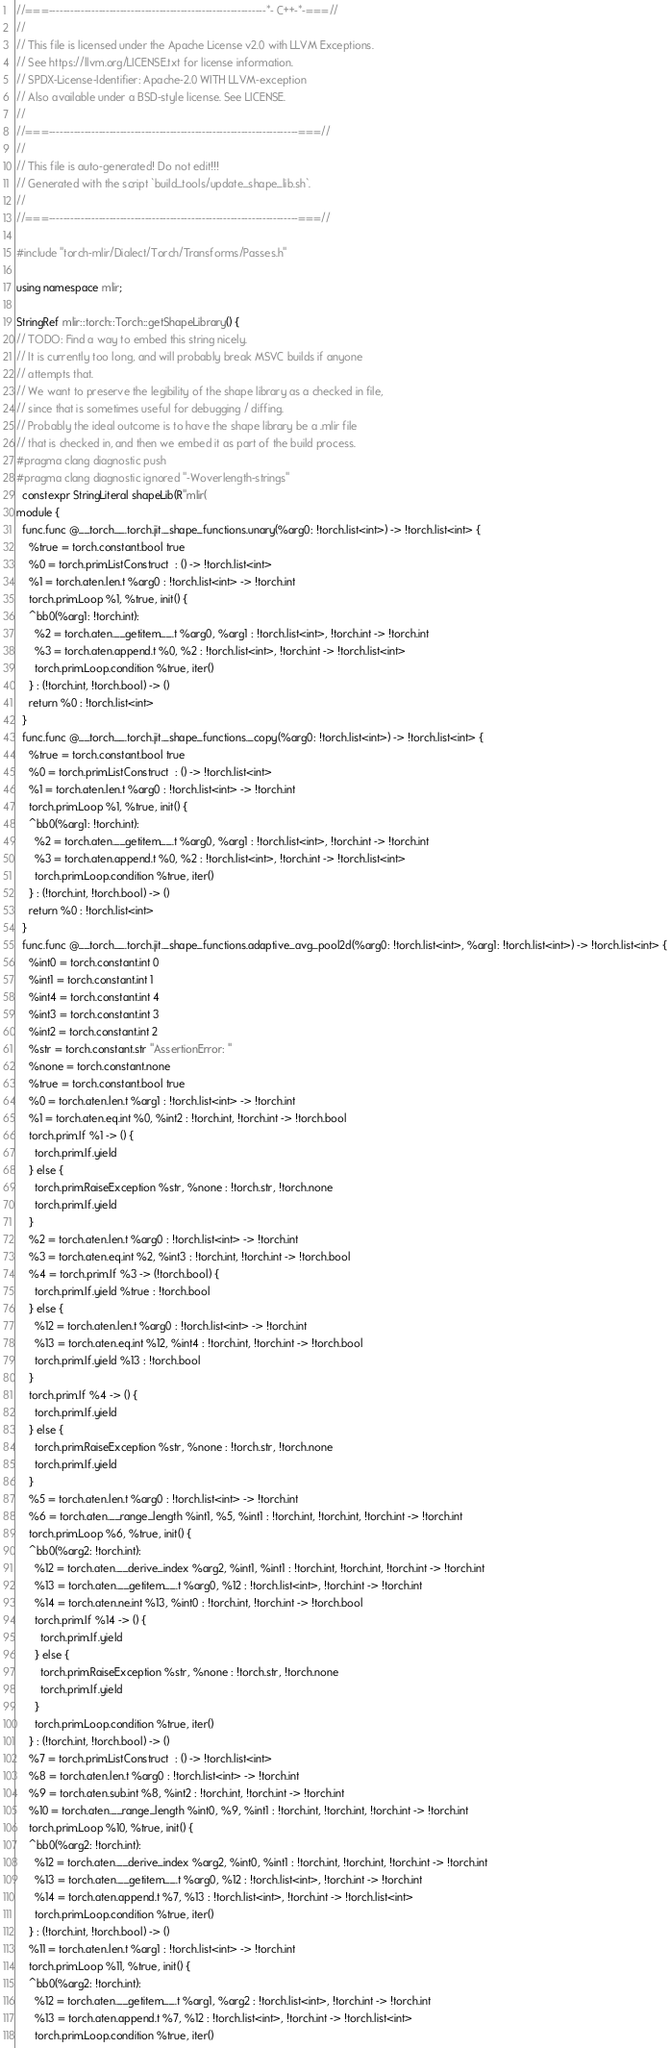<code> <loc_0><loc_0><loc_500><loc_500><_C++_>//===-------------------------------------------------------------*- C++-*-===//
//
// This file is licensed under the Apache License v2.0 with LLVM Exceptions.
// See https://llvm.org/LICENSE.txt for license information.
// SPDX-License-Identifier: Apache-2.0 WITH LLVM-exception
// Also available under a BSD-style license. See LICENSE.
//
//===----------------------------------------------------------------------===//
//
// This file is auto-generated! Do not edit!!!
// Generated with the script `build_tools/update_shape_lib.sh`.
//
//===----------------------------------------------------------------------===//

#include "torch-mlir/Dialect/Torch/Transforms/Passes.h"

using namespace mlir;

StringRef mlir::torch::Torch::getShapeLibrary() {
// TODO: Find a way to embed this string nicely.
// It is currently too long, and will probably break MSVC builds if anyone
// attempts that.
// We want to preserve the legibility of the shape library as a checked in file,
// since that is sometimes useful for debugging / diffing.
// Probably the ideal outcome is to have the shape library be a .mlir file
// that is checked in, and then we embed it as part of the build process.
#pragma clang diagnostic push
#pragma clang diagnostic ignored "-Woverlength-strings"
  constexpr StringLiteral shapeLib(R"mlir(
module {
  func.func @__torch__.torch.jit._shape_functions.unary(%arg0: !torch.list<int>) -> !torch.list<int> {
    %true = torch.constant.bool true
    %0 = torch.prim.ListConstruct  : () -> !torch.list<int>
    %1 = torch.aten.len.t %arg0 : !torch.list<int> -> !torch.int
    torch.prim.Loop %1, %true, init() {
    ^bb0(%arg1: !torch.int):
      %2 = torch.aten.__getitem__.t %arg0, %arg1 : !torch.list<int>, !torch.int -> !torch.int
      %3 = torch.aten.append.t %0, %2 : !torch.list<int>, !torch.int -> !torch.list<int>
      torch.prim.Loop.condition %true, iter()
    } : (!torch.int, !torch.bool) -> ()
    return %0 : !torch.list<int>
  }
  func.func @__torch__.torch.jit._shape_functions._copy(%arg0: !torch.list<int>) -> !torch.list<int> {
    %true = torch.constant.bool true
    %0 = torch.prim.ListConstruct  : () -> !torch.list<int>
    %1 = torch.aten.len.t %arg0 : !torch.list<int> -> !torch.int
    torch.prim.Loop %1, %true, init() {
    ^bb0(%arg1: !torch.int):
      %2 = torch.aten.__getitem__.t %arg0, %arg1 : !torch.list<int>, !torch.int -> !torch.int
      %3 = torch.aten.append.t %0, %2 : !torch.list<int>, !torch.int -> !torch.list<int>
      torch.prim.Loop.condition %true, iter()
    } : (!torch.int, !torch.bool) -> ()
    return %0 : !torch.list<int>
  }
  func.func @__torch__.torch.jit._shape_functions.adaptive_avg_pool2d(%arg0: !torch.list<int>, %arg1: !torch.list<int>) -> !torch.list<int> {
    %int0 = torch.constant.int 0
    %int1 = torch.constant.int 1
    %int4 = torch.constant.int 4
    %int3 = torch.constant.int 3
    %int2 = torch.constant.int 2
    %str = torch.constant.str "AssertionError: "
    %none = torch.constant.none
    %true = torch.constant.bool true
    %0 = torch.aten.len.t %arg1 : !torch.list<int> -> !torch.int
    %1 = torch.aten.eq.int %0, %int2 : !torch.int, !torch.int -> !torch.bool
    torch.prim.If %1 -> () {
      torch.prim.If.yield
    } else {
      torch.prim.RaiseException %str, %none : !torch.str, !torch.none
      torch.prim.If.yield
    }
    %2 = torch.aten.len.t %arg0 : !torch.list<int> -> !torch.int
    %3 = torch.aten.eq.int %2, %int3 : !torch.int, !torch.int -> !torch.bool
    %4 = torch.prim.If %3 -> (!torch.bool) {
      torch.prim.If.yield %true : !torch.bool
    } else {
      %12 = torch.aten.len.t %arg0 : !torch.list<int> -> !torch.int
      %13 = torch.aten.eq.int %12, %int4 : !torch.int, !torch.int -> !torch.bool
      torch.prim.If.yield %13 : !torch.bool
    }
    torch.prim.If %4 -> () {
      torch.prim.If.yield
    } else {
      torch.prim.RaiseException %str, %none : !torch.str, !torch.none
      torch.prim.If.yield
    }
    %5 = torch.aten.len.t %arg0 : !torch.list<int> -> !torch.int
    %6 = torch.aten.__range_length %int1, %5, %int1 : !torch.int, !torch.int, !torch.int -> !torch.int
    torch.prim.Loop %6, %true, init() {
    ^bb0(%arg2: !torch.int):
      %12 = torch.aten.__derive_index %arg2, %int1, %int1 : !torch.int, !torch.int, !torch.int -> !torch.int
      %13 = torch.aten.__getitem__.t %arg0, %12 : !torch.list<int>, !torch.int -> !torch.int
      %14 = torch.aten.ne.int %13, %int0 : !torch.int, !torch.int -> !torch.bool
      torch.prim.If %14 -> () {
        torch.prim.If.yield
      } else {
        torch.prim.RaiseException %str, %none : !torch.str, !torch.none
        torch.prim.If.yield
      }
      torch.prim.Loop.condition %true, iter()
    } : (!torch.int, !torch.bool) -> ()
    %7 = torch.prim.ListConstruct  : () -> !torch.list<int>
    %8 = torch.aten.len.t %arg0 : !torch.list<int> -> !torch.int
    %9 = torch.aten.sub.int %8, %int2 : !torch.int, !torch.int -> !torch.int
    %10 = torch.aten.__range_length %int0, %9, %int1 : !torch.int, !torch.int, !torch.int -> !torch.int
    torch.prim.Loop %10, %true, init() {
    ^bb0(%arg2: !torch.int):
      %12 = torch.aten.__derive_index %arg2, %int0, %int1 : !torch.int, !torch.int, !torch.int -> !torch.int
      %13 = torch.aten.__getitem__.t %arg0, %12 : !torch.list<int>, !torch.int -> !torch.int
      %14 = torch.aten.append.t %7, %13 : !torch.list<int>, !torch.int -> !torch.list<int>
      torch.prim.Loop.condition %true, iter()
    } : (!torch.int, !torch.bool) -> ()
    %11 = torch.aten.len.t %arg1 : !torch.list<int> -> !torch.int
    torch.prim.Loop %11, %true, init() {
    ^bb0(%arg2: !torch.int):
      %12 = torch.aten.__getitem__.t %arg1, %arg2 : !torch.list<int>, !torch.int -> !torch.int
      %13 = torch.aten.append.t %7, %12 : !torch.list<int>, !torch.int -> !torch.list<int>
      torch.prim.Loop.condition %true, iter()</code> 